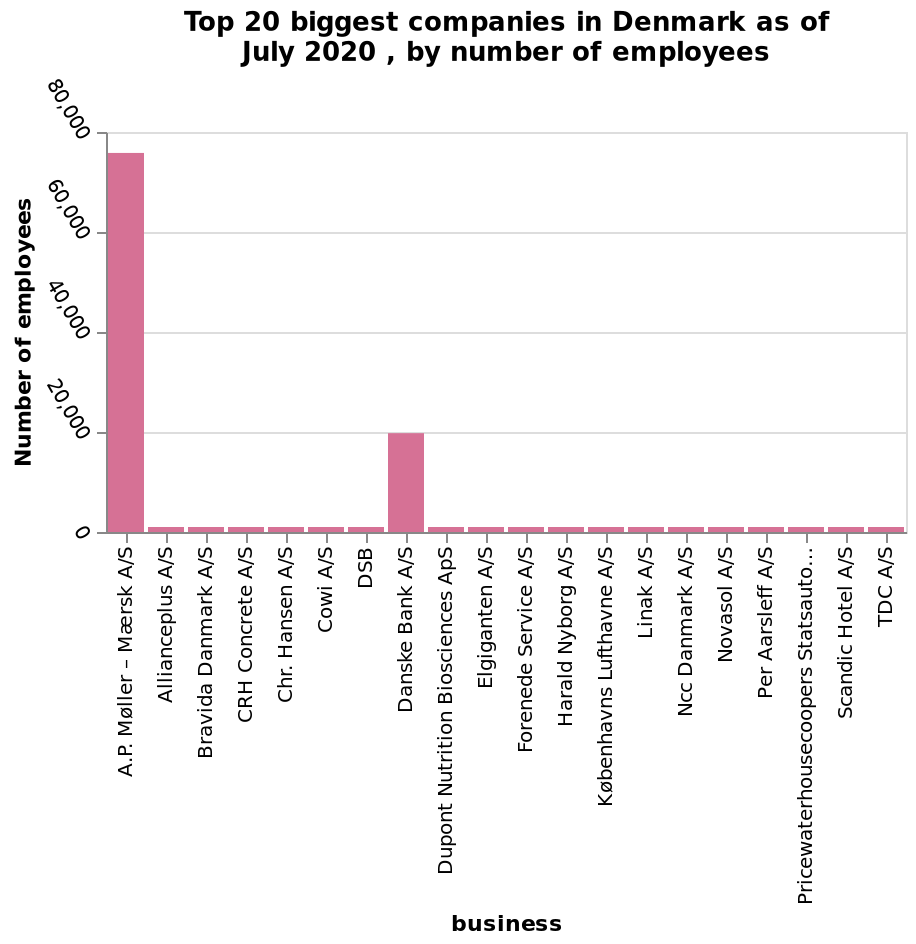<image>
please enumerates aspects of the construction of the chart Top 20 biggest companies in Denmark as of July 2020 , by number of employees is a bar diagram. A categorical scale with A.P. Møller – Mærsk A/S on one end and TDC A/S at the other can be seen on the x-axis, marked business. On the y-axis, Number of employees is shown. Which company is located at the far right end of the x-axis? TDC A/S is located at the far right end of the x-axis. Which company is the second biggest in Denmark?  Danske Bank is the second biggest company in Denmark. Is TDC A/S located at the far left end of the x-axis? No.TDC A/S is located at the far right end of the x-axis. 